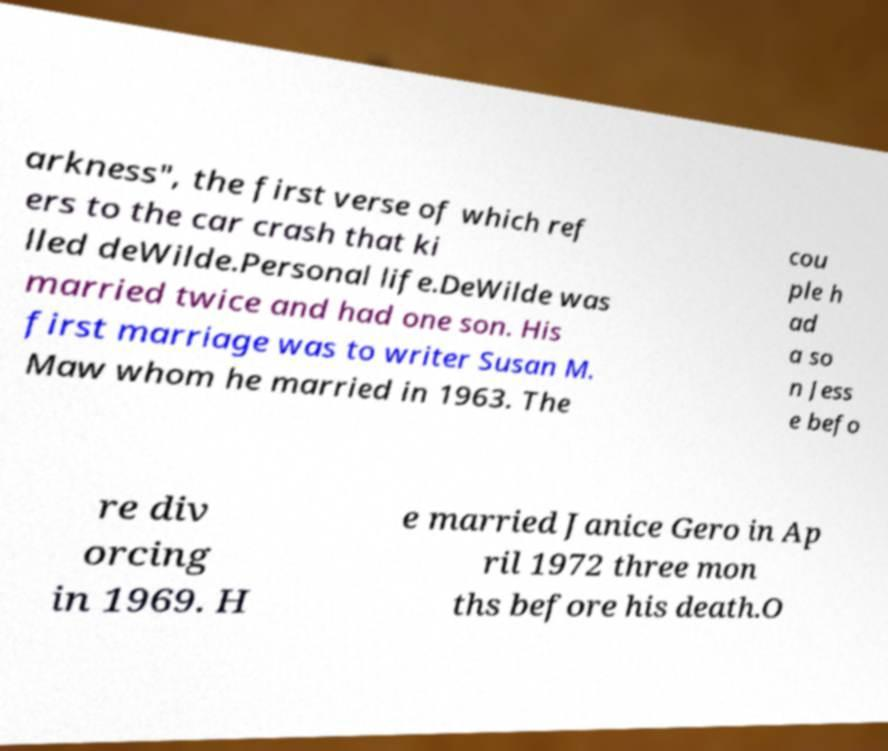For documentation purposes, I need the text within this image transcribed. Could you provide that? arkness", the first verse of which ref ers to the car crash that ki lled deWilde.Personal life.DeWilde was married twice and had one son. His first marriage was to writer Susan M. Maw whom he married in 1963. The cou ple h ad a so n Jess e befo re div orcing in 1969. H e married Janice Gero in Ap ril 1972 three mon ths before his death.O 